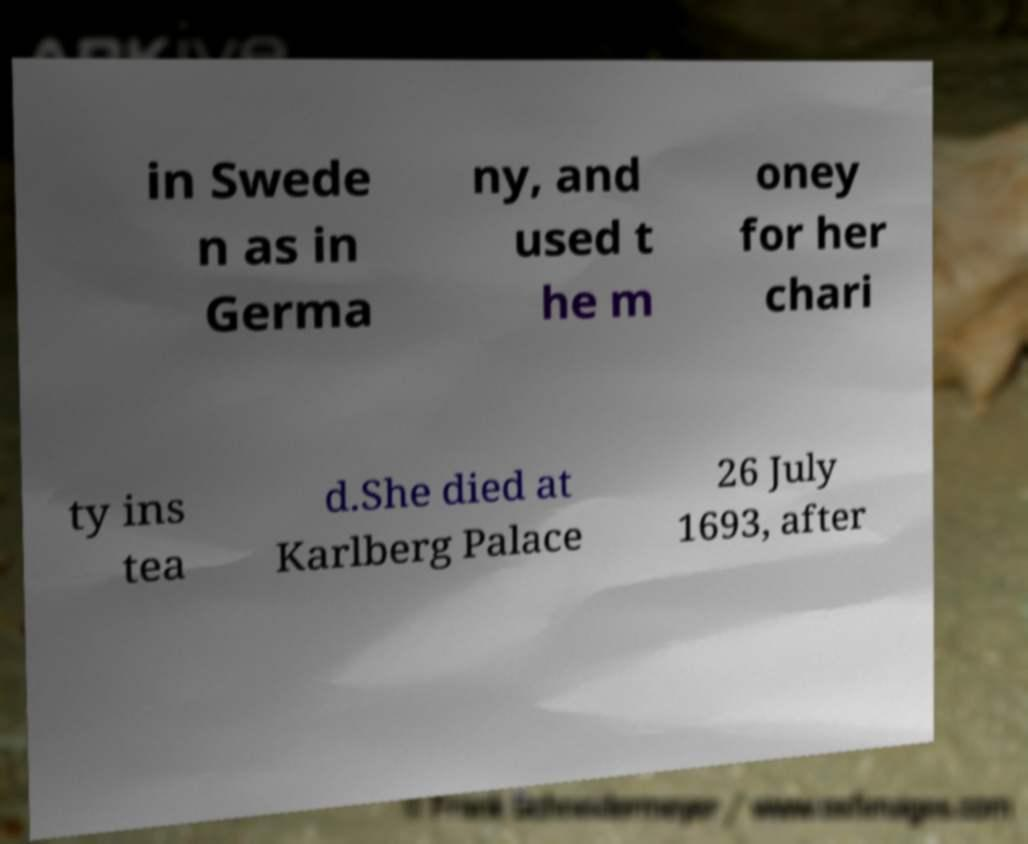Can you accurately transcribe the text from the provided image for me? in Swede n as in Germa ny, and used t he m oney for her chari ty ins tea d.She died at Karlberg Palace 26 July 1693, after 